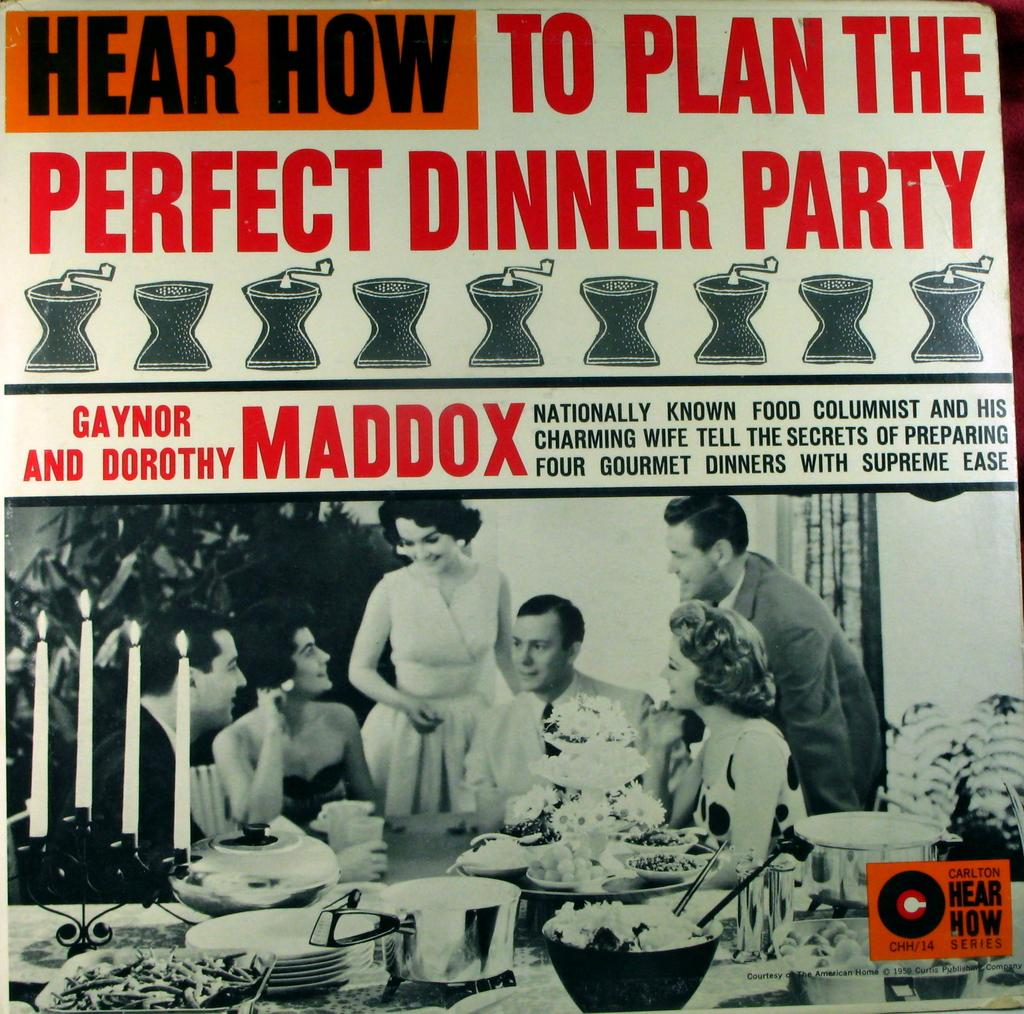What is the main subject of the image? The main subject of the image is a poster. What can be found on the poster? There is text on the poster. Are there any images or illustrations on the poster? Yes, there are depictions of persons and other objects at the bottom of the image. How many sheep are visible in the image? There are no sheep present in the image; it features a poster with text and depictions of persons and other objects. 